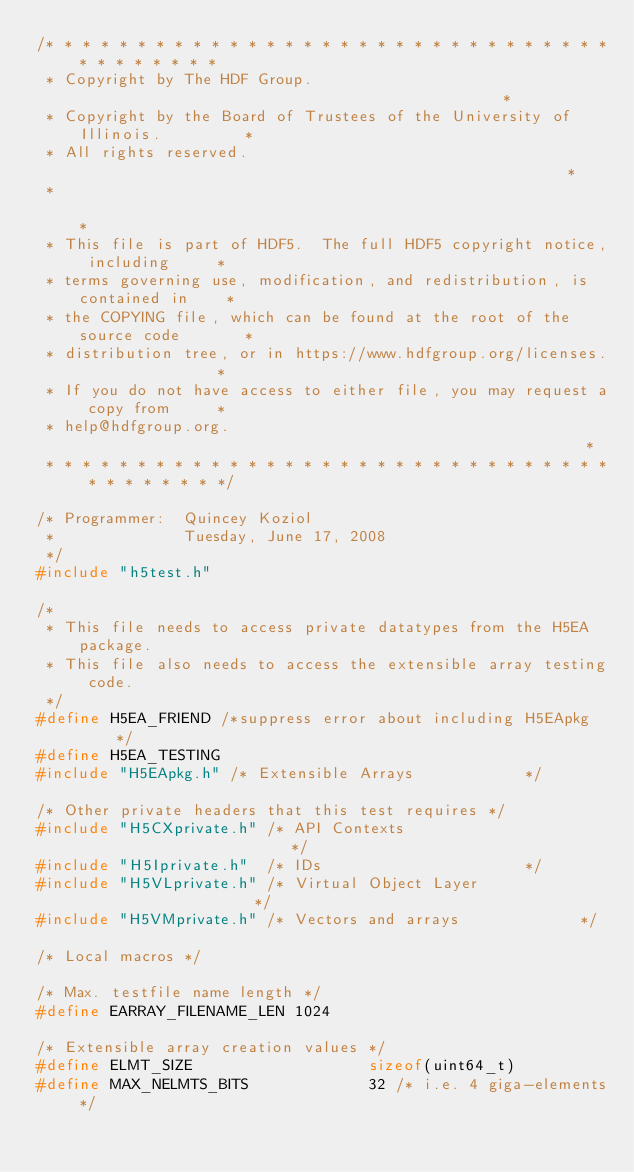<code> <loc_0><loc_0><loc_500><loc_500><_C_>/* * * * * * * * * * * * * * * * * * * * * * * * * * * * * * * * * * * * * * *
 * Copyright by The HDF Group.                                               *
 * Copyright by the Board of Trustees of the University of Illinois.         *
 * All rights reserved.                                                      *
 *                                                                           *
 * This file is part of HDF5.  The full HDF5 copyright notice, including     *
 * terms governing use, modification, and redistribution, is contained in    *
 * the COPYING file, which can be found at the root of the source code       *
 * distribution tree, or in https://www.hdfgroup.org/licenses.               *
 * If you do not have access to either file, you may request a copy from     *
 * help@hdfgroup.org.                                                        *
 * * * * * * * * * * * * * * * * * * * * * * * * * * * * * * * * * * * * * * */

/* Programmer:  Quincey Koziol
 *              Tuesday, June 17, 2008
 */
#include "h5test.h"

/*
 * This file needs to access private datatypes from the H5EA package.
 * This file also needs to access the extensible array testing code.
 */
#define H5EA_FRIEND /*suppress error about including H5EApkg      */
#define H5EA_TESTING
#include "H5EApkg.h" /* Extensible Arrays            */

/* Other private headers that this test requires */
#include "H5CXprivate.h" /* API Contexts                         */
#include "H5Iprivate.h"  /* IDs                      */
#include "H5VLprivate.h" /* Virtual Object Layer                     */
#include "H5VMprivate.h" /* Vectors and arrays             */

/* Local macros */

/* Max. testfile name length */
#define EARRAY_FILENAME_LEN 1024

/* Extensible array creation values */
#define ELMT_SIZE                   sizeof(uint64_t)
#define MAX_NELMTS_BITS             32 /* i.e. 4 giga-elements */</code> 